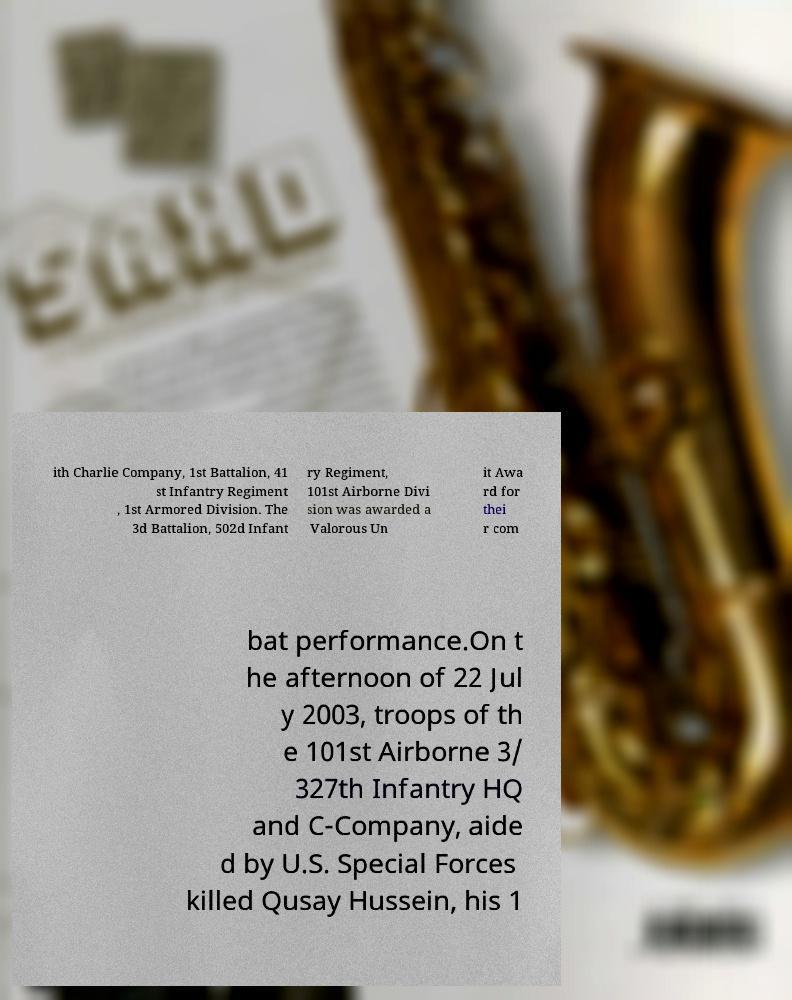Could you assist in decoding the text presented in this image and type it out clearly? ith Charlie Company, 1st Battalion, 41 st Infantry Regiment , 1st Armored Division. The 3d Battalion, 502d Infant ry Regiment, 101st Airborne Divi sion was awarded a Valorous Un it Awa rd for thei r com bat performance.On t he afternoon of 22 Jul y 2003, troops of th e 101st Airborne 3/ 327th Infantry HQ and C-Company, aide d by U.S. Special Forces killed Qusay Hussein, his 1 